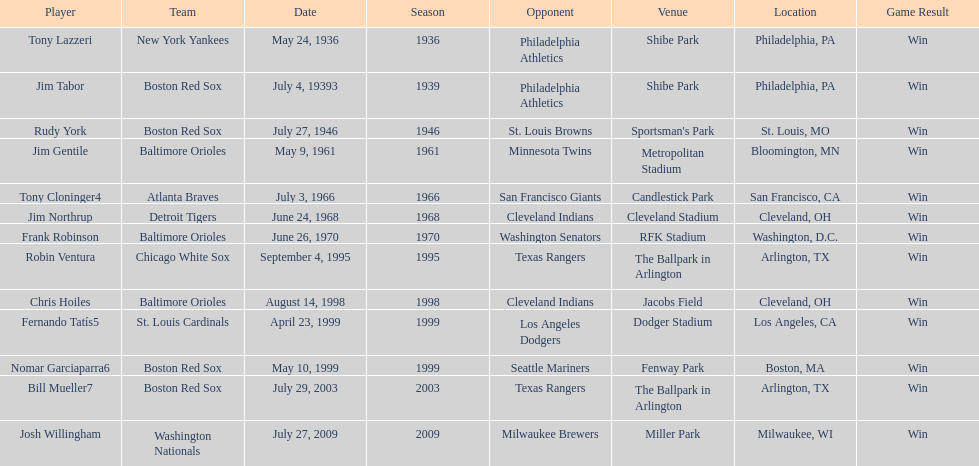Which teams faced off at miller park? Washington Nationals, Milwaukee Brewers. 